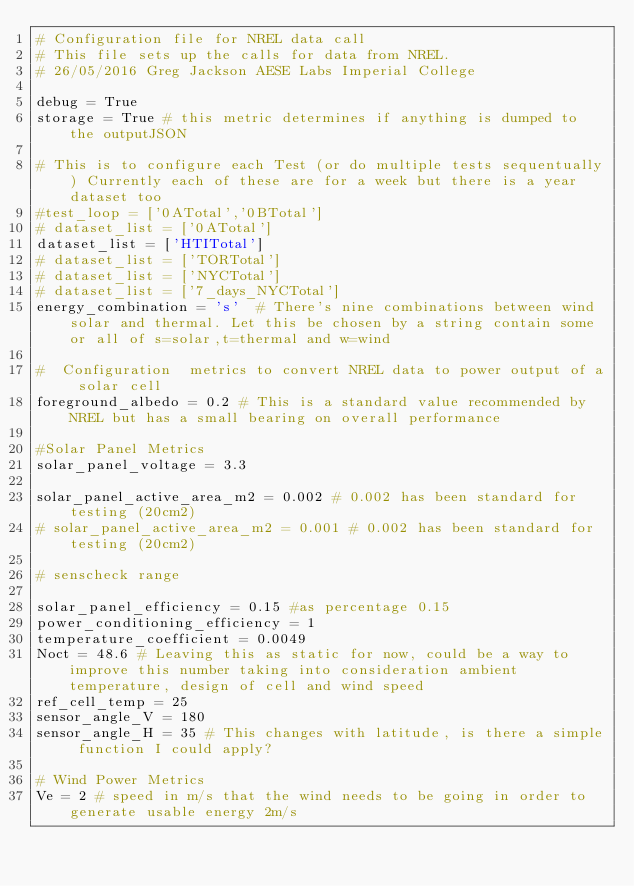<code> <loc_0><loc_0><loc_500><loc_500><_Python_># Configuration file for NREL data call
# This file sets up the calls for data from NREL.
# 26/05/2016 Greg Jackson AESE Labs Imperial College

debug = True
storage = True # this metric determines if anything is dumped to the outputJSON

# This is to configure each Test (or do multiple tests sequentually) Currently each of these are for a week but there is a year dataset too
#test_loop = ['0ATotal','0BTotal']
# dataset_list = ['0ATotal']
dataset_list = ['HTITotal']
# dataset_list = ['TORTotal']
# dataset_list = ['NYCTotal']
# dataset_list = ['7_days_NYCTotal']
energy_combination = 's'  # There's nine combinations between wind solar and thermal. Let this be chosen by a string contain some or all of s=solar,t=thermal and w=wind

#  Configuration  metrics to convert NREL data to power output of a solar cell
foreground_albedo = 0.2 # This is a standard value recommended by NREL but has a small bearing on overall performance

#Solar Panel Metrics
solar_panel_voltage = 3.3

solar_panel_active_area_m2 = 0.002 # 0.002 has been standard for testing (20cm2)
# solar_panel_active_area_m2 = 0.001 # 0.002 has been standard for testing (20cm2)

# senscheck range

solar_panel_efficiency = 0.15 #as percentage 0.15
power_conditioning_efficiency = 1
temperature_coefficient = 0.0049
Noct = 48.6 # Leaving this as static for now, could be a way to improve this number taking into consideration ambient temperature, design of cell and wind speed
ref_cell_temp = 25
sensor_angle_V = 180
sensor_angle_H = 35 # This changes with latitude, is there a simple function I could apply?

# Wind Power Metrics
Ve = 2 # speed in m/s that the wind needs to be going in order to generate usable energy 2m/s</code> 